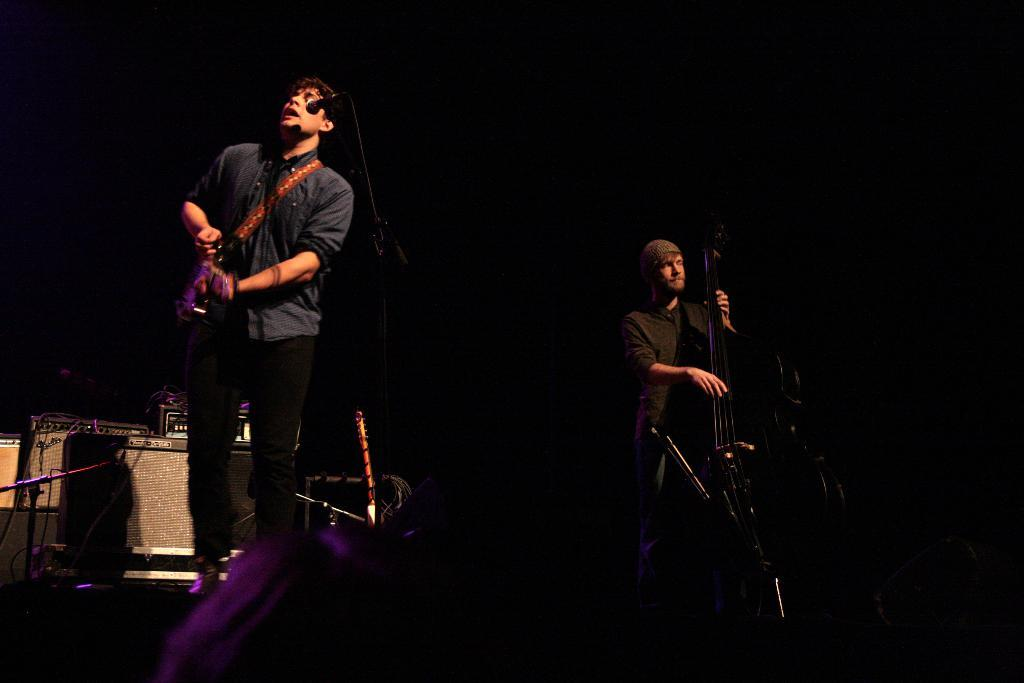What is the person in the image doing? The person is playing a guitar. Where is the person located in relation to the microphone? The person is in front of a microphone. What other objects can be seen in the image? There are electronic devices in the image. What type of wrist support is the person using while playing the guitar? There is no wrist support visible in the image, as the person is playing the guitar without any additional support. 